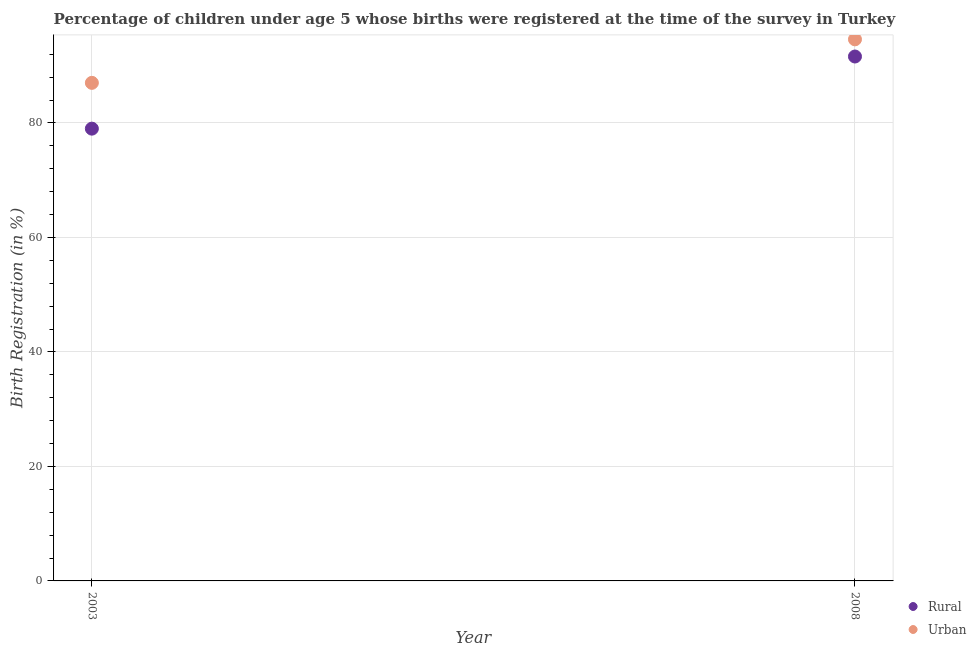Is the number of dotlines equal to the number of legend labels?
Provide a succinct answer. Yes. What is the rural birth registration in 2003?
Your response must be concise. 79. Across all years, what is the maximum urban birth registration?
Make the answer very short. 94.6. In which year was the rural birth registration minimum?
Your answer should be very brief. 2003. What is the total urban birth registration in the graph?
Give a very brief answer. 181.6. What is the difference between the rural birth registration in 2003 and that in 2008?
Provide a succinct answer. -12.6. What is the difference between the urban birth registration in 2003 and the rural birth registration in 2008?
Ensure brevity in your answer.  -4.6. What is the average urban birth registration per year?
Give a very brief answer. 90.8. In the year 2008, what is the difference between the urban birth registration and rural birth registration?
Give a very brief answer. 3. In how many years, is the urban birth registration greater than 68 %?
Your answer should be very brief. 2. What is the ratio of the rural birth registration in 2003 to that in 2008?
Make the answer very short. 0.86. Does the rural birth registration monotonically increase over the years?
Your response must be concise. Yes. Is the urban birth registration strictly greater than the rural birth registration over the years?
Keep it short and to the point. Yes. Is the urban birth registration strictly less than the rural birth registration over the years?
Provide a short and direct response. No. How many years are there in the graph?
Your answer should be compact. 2. Does the graph contain grids?
Provide a short and direct response. Yes. Where does the legend appear in the graph?
Make the answer very short. Bottom right. How are the legend labels stacked?
Ensure brevity in your answer.  Vertical. What is the title of the graph?
Provide a short and direct response. Percentage of children under age 5 whose births were registered at the time of the survey in Turkey. What is the label or title of the X-axis?
Your answer should be compact. Year. What is the label or title of the Y-axis?
Your answer should be very brief. Birth Registration (in %). What is the Birth Registration (in %) of Rural in 2003?
Give a very brief answer. 79. What is the Birth Registration (in %) in Rural in 2008?
Your response must be concise. 91.6. What is the Birth Registration (in %) of Urban in 2008?
Offer a very short reply. 94.6. Across all years, what is the maximum Birth Registration (in %) of Rural?
Provide a succinct answer. 91.6. Across all years, what is the maximum Birth Registration (in %) of Urban?
Keep it short and to the point. 94.6. Across all years, what is the minimum Birth Registration (in %) of Rural?
Make the answer very short. 79. Across all years, what is the minimum Birth Registration (in %) in Urban?
Provide a succinct answer. 87. What is the total Birth Registration (in %) in Rural in the graph?
Make the answer very short. 170.6. What is the total Birth Registration (in %) of Urban in the graph?
Offer a very short reply. 181.6. What is the difference between the Birth Registration (in %) of Rural in 2003 and that in 2008?
Offer a very short reply. -12.6. What is the difference between the Birth Registration (in %) of Rural in 2003 and the Birth Registration (in %) of Urban in 2008?
Give a very brief answer. -15.6. What is the average Birth Registration (in %) of Rural per year?
Give a very brief answer. 85.3. What is the average Birth Registration (in %) of Urban per year?
Offer a very short reply. 90.8. In the year 2003, what is the difference between the Birth Registration (in %) in Rural and Birth Registration (in %) in Urban?
Your answer should be compact. -8. In the year 2008, what is the difference between the Birth Registration (in %) in Rural and Birth Registration (in %) in Urban?
Provide a succinct answer. -3. What is the ratio of the Birth Registration (in %) of Rural in 2003 to that in 2008?
Ensure brevity in your answer.  0.86. What is the ratio of the Birth Registration (in %) of Urban in 2003 to that in 2008?
Keep it short and to the point. 0.92. What is the difference between the highest and the second highest Birth Registration (in %) of Rural?
Ensure brevity in your answer.  12.6. What is the difference between the highest and the second highest Birth Registration (in %) of Urban?
Keep it short and to the point. 7.6. 